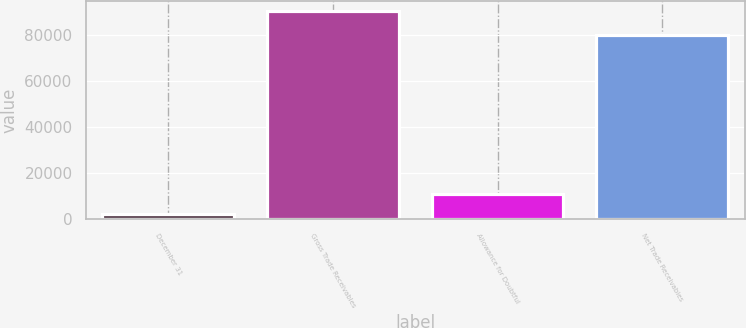Convert chart to OTSL. <chart><loc_0><loc_0><loc_500><loc_500><bar_chart><fcel>December 31<fcel>Gross Trade Receivables<fcel>Allowance for Doubtful<fcel>Net Trade Receivables<nl><fcel>2015<fcel>90212<fcel>10834.7<fcel>79864<nl></chart> 